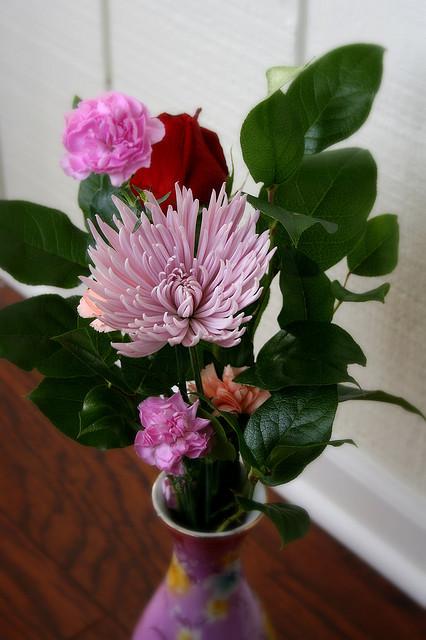How many flowers are in the pitcher?
Short answer required. 5. What species of flower is in the back facing away?
Give a very brief answer. Rose. Are flowers are in full bloom?
Answer briefly. Yes. What color is the counter?
Be succinct. Brown. Are the leaves a summer  color?
Answer briefly. Yes. What colors are the flowers?
Write a very short answer. Pink. Are these daisies?
Be succinct. No. Is the floor made of wood?
Answer briefly. Yes. What are the flowers in?
Give a very brief answer. Vase. What color is the vase?
Write a very short answer. Purple. What color are the flowers?
Keep it brief. Pink. 